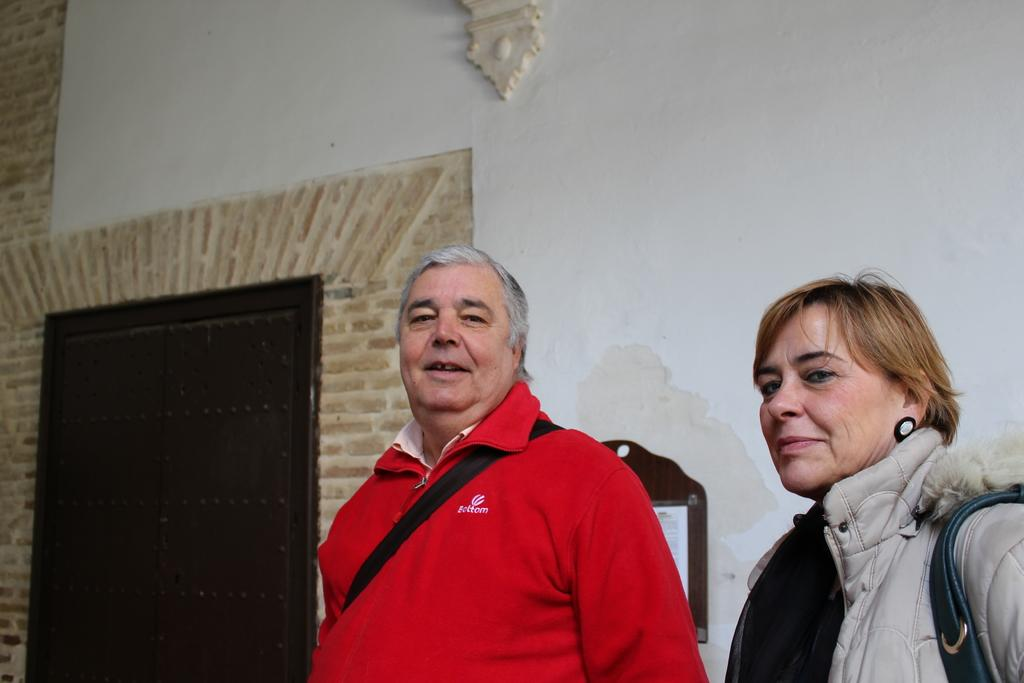How many people are in the image? There are two persons standing in the image. What can be seen in the background of the image? There is a brown and white wall in the background, and a door is also visible. What is attached to the wall in the background? A board is attached to the wall in the background. What type of note is the person on the left holding in the image? There is no note visible in the image; the two persons are not holding anything. 